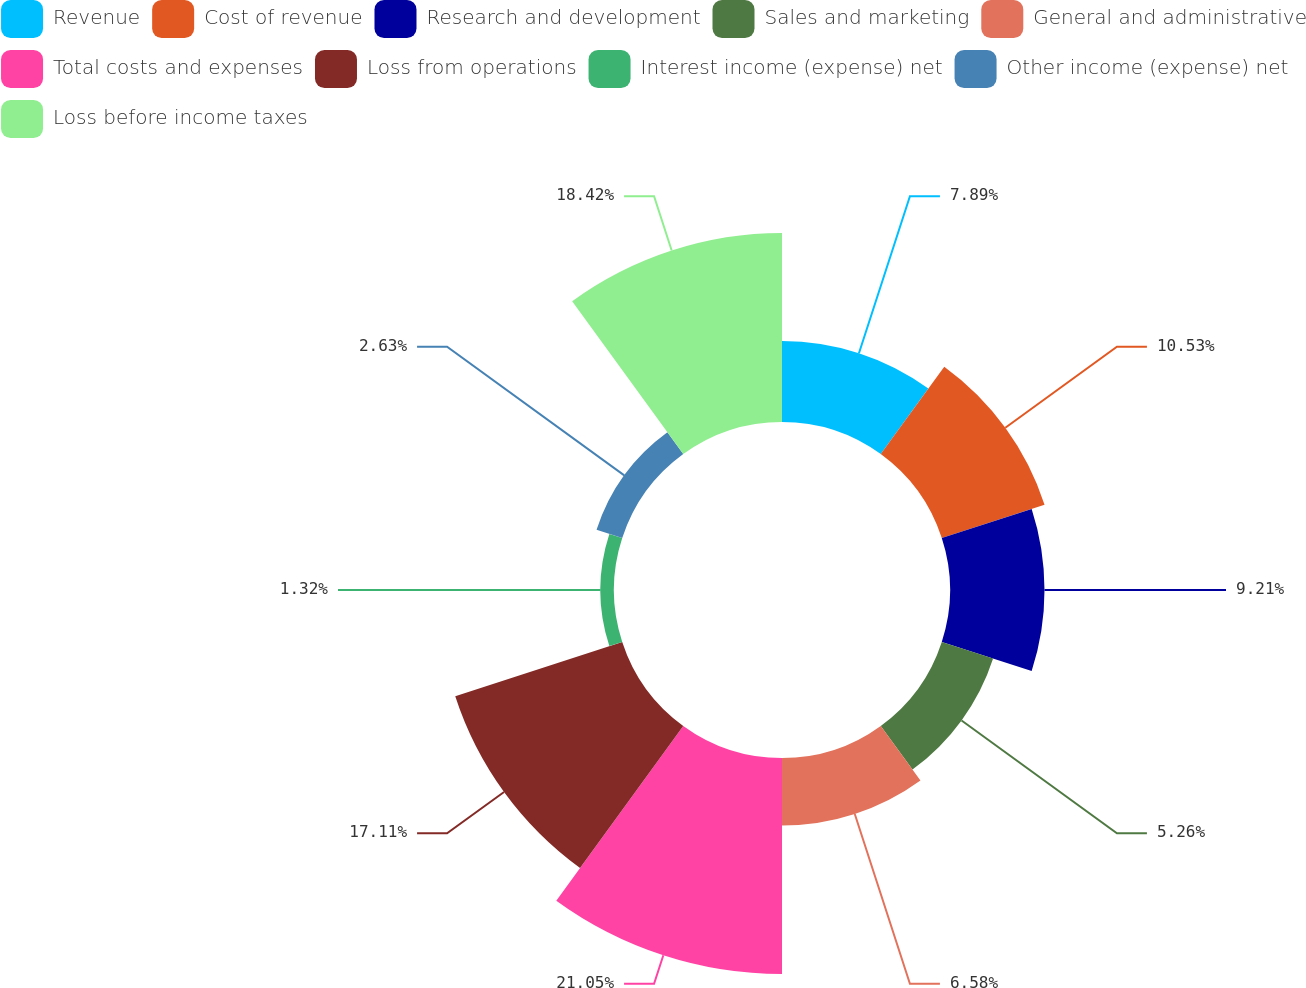Convert chart. <chart><loc_0><loc_0><loc_500><loc_500><pie_chart><fcel>Revenue<fcel>Cost of revenue<fcel>Research and development<fcel>Sales and marketing<fcel>General and administrative<fcel>Total costs and expenses<fcel>Loss from operations<fcel>Interest income (expense) net<fcel>Other income (expense) net<fcel>Loss before income taxes<nl><fcel>7.89%<fcel>10.53%<fcel>9.21%<fcel>5.26%<fcel>6.58%<fcel>21.05%<fcel>17.11%<fcel>1.32%<fcel>2.63%<fcel>18.42%<nl></chart> 